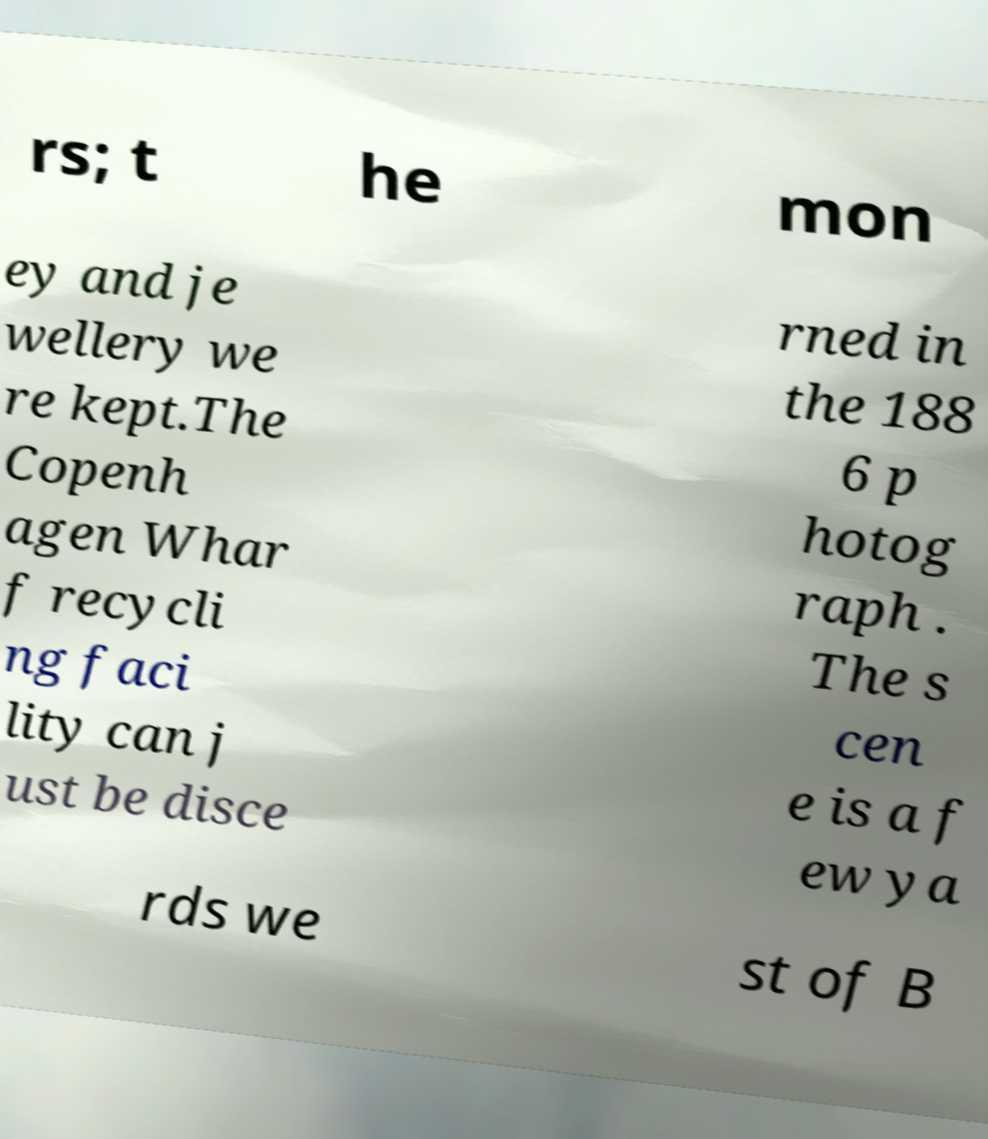I need the written content from this picture converted into text. Can you do that? rs; t he mon ey and je wellery we re kept.The Copenh agen Whar f recycli ng faci lity can j ust be disce rned in the 188 6 p hotog raph . The s cen e is a f ew ya rds we st of B 